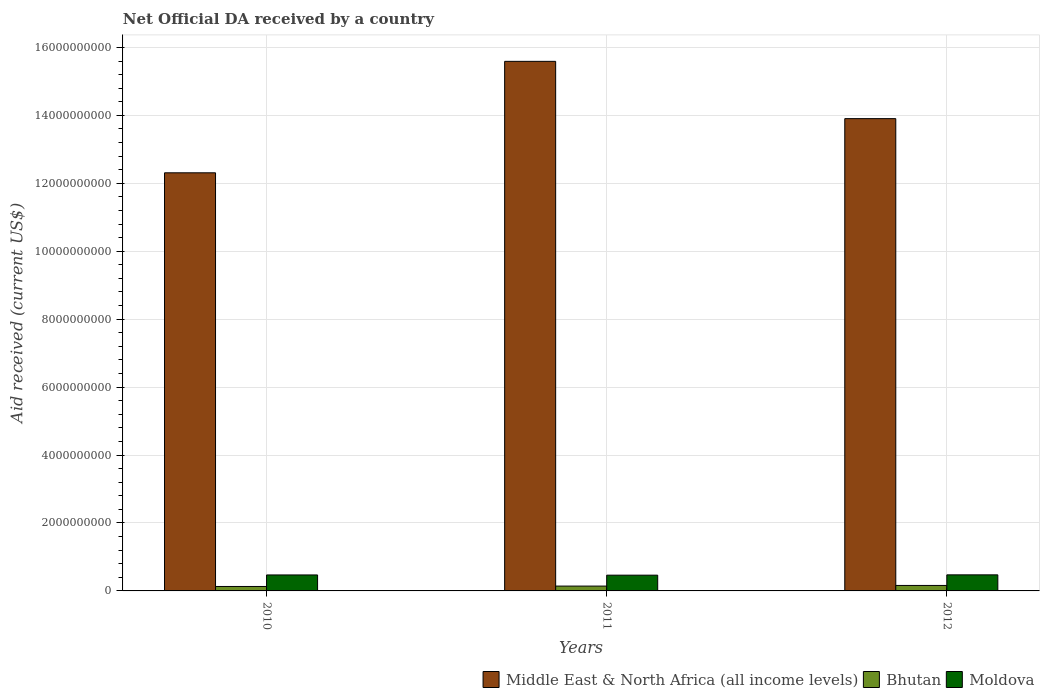How many groups of bars are there?
Offer a very short reply. 3. How many bars are there on the 3rd tick from the left?
Provide a succinct answer. 3. What is the label of the 2nd group of bars from the left?
Ensure brevity in your answer.  2011. In how many cases, is the number of bars for a given year not equal to the number of legend labels?
Offer a very short reply. 0. What is the net official development assistance aid received in Middle East & North Africa (all income levels) in 2010?
Your answer should be compact. 1.23e+1. Across all years, what is the maximum net official development assistance aid received in Bhutan?
Provide a succinct answer. 1.61e+08. Across all years, what is the minimum net official development assistance aid received in Middle East & North Africa (all income levels)?
Provide a short and direct response. 1.23e+1. In which year was the net official development assistance aid received in Middle East & North Africa (all income levels) maximum?
Your answer should be very brief. 2011. What is the total net official development assistance aid received in Bhutan in the graph?
Provide a succinct answer. 4.35e+08. What is the difference between the net official development assistance aid received in Moldova in 2011 and that in 2012?
Make the answer very short. -8.99e+06. What is the difference between the net official development assistance aid received in Moldova in 2010 and the net official development assistance aid received in Middle East & North Africa (all income levels) in 2012?
Your answer should be compact. -1.34e+1. What is the average net official development assistance aid received in Moldova per year?
Ensure brevity in your answer.  4.69e+08. In the year 2012, what is the difference between the net official development assistance aid received in Moldova and net official development assistance aid received in Bhutan?
Your answer should be compact. 3.12e+08. In how many years, is the net official development assistance aid received in Bhutan greater than 4400000000 US$?
Your answer should be compact. 0. What is the ratio of the net official development assistance aid received in Bhutan in 2010 to that in 2012?
Provide a short and direct response. 0.81. Is the difference between the net official development assistance aid received in Moldova in 2011 and 2012 greater than the difference between the net official development assistance aid received in Bhutan in 2011 and 2012?
Offer a very short reply. Yes. What is the difference between the highest and the second highest net official development assistance aid received in Middle East & North Africa (all income levels)?
Keep it short and to the point. 1.69e+09. What is the difference between the highest and the lowest net official development assistance aid received in Moldova?
Your answer should be very brief. 8.99e+06. In how many years, is the net official development assistance aid received in Middle East & North Africa (all income levels) greater than the average net official development assistance aid received in Middle East & North Africa (all income levels) taken over all years?
Offer a very short reply. 1. Is the sum of the net official development assistance aid received in Bhutan in 2011 and 2012 greater than the maximum net official development assistance aid received in Middle East & North Africa (all income levels) across all years?
Your answer should be very brief. No. What does the 3rd bar from the left in 2011 represents?
Give a very brief answer. Moldova. What does the 3rd bar from the right in 2010 represents?
Make the answer very short. Middle East & North Africa (all income levels). How many bars are there?
Offer a terse response. 9. How many years are there in the graph?
Your answer should be compact. 3. What is the difference between two consecutive major ticks on the Y-axis?
Ensure brevity in your answer.  2.00e+09. Does the graph contain any zero values?
Keep it short and to the point. No. Does the graph contain grids?
Your answer should be compact. Yes. How many legend labels are there?
Offer a terse response. 3. How are the legend labels stacked?
Your answer should be compact. Horizontal. What is the title of the graph?
Give a very brief answer. Net Official DA received by a country. What is the label or title of the X-axis?
Your answer should be very brief. Years. What is the label or title of the Y-axis?
Your response must be concise. Aid received (current US$). What is the Aid received (current US$) of Middle East & North Africa (all income levels) in 2010?
Your answer should be compact. 1.23e+1. What is the Aid received (current US$) of Bhutan in 2010?
Make the answer very short. 1.31e+08. What is the Aid received (current US$) in Moldova in 2010?
Make the answer very short. 4.70e+08. What is the Aid received (current US$) in Middle East & North Africa (all income levels) in 2011?
Your response must be concise. 1.56e+1. What is the Aid received (current US$) of Bhutan in 2011?
Keep it short and to the point. 1.42e+08. What is the Aid received (current US$) in Moldova in 2011?
Offer a terse response. 4.64e+08. What is the Aid received (current US$) of Middle East & North Africa (all income levels) in 2012?
Your answer should be compact. 1.39e+1. What is the Aid received (current US$) in Bhutan in 2012?
Your response must be concise. 1.61e+08. What is the Aid received (current US$) in Moldova in 2012?
Your answer should be very brief. 4.73e+08. Across all years, what is the maximum Aid received (current US$) of Middle East & North Africa (all income levels)?
Your answer should be very brief. 1.56e+1. Across all years, what is the maximum Aid received (current US$) of Bhutan?
Your answer should be compact. 1.61e+08. Across all years, what is the maximum Aid received (current US$) of Moldova?
Make the answer very short. 4.73e+08. Across all years, what is the minimum Aid received (current US$) in Middle East & North Africa (all income levels)?
Offer a very short reply. 1.23e+1. Across all years, what is the minimum Aid received (current US$) in Bhutan?
Your answer should be compact. 1.31e+08. Across all years, what is the minimum Aid received (current US$) in Moldova?
Keep it short and to the point. 4.64e+08. What is the total Aid received (current US$) in Middle East & North Africa (all income levels) in the graph?
Give a very brief answer. 4.18e+1. What is the total Aid received (current US$) of Bhutan in the graph?
Your answer should be very brief. 4.35e+08. What is the total Aid received (current US$) in Moldova in the graph?
Give a very brief answer. 1.41e+09. What is the difference between the Aid received (current US$) of Middle East & North Africa (all income levels) in 2010 and that in 2011?
Keep it short and to the point. -3.28e+09. What is the difference between the Aid received (current US$) of Bhutan in 2010 and that in 2011?
Offer a terse response. -1.14e+07. What is the difference between the Aid received (current US$) in Moldova in 2010 and that in 2011?
Keep it short and to the point. 6.31e+06. What is the difference between the Aid received (current US$) in Middle East & North Africa (all income levels) in 2010 and that in 2012?
Your answer should be very brief. -1.59e+09. What is the difference between the Aid received (current US$) in Bhutan in 2010 and that in 2012?
Your answer should be compact. -3.03e+07. What is the difference between the Aid received (current US$) in Moldova in 2010 and that in 2012?
Provide a short and direct response. -2.68e+06. What is the difference between the Aid received (current US$) of Middle East & North Africa (all income levels) in 2011 and that in 2012?
Offer a very short reply. 1.69e+09. What is the difference between the Aid received (current US$) in Bhutan in 2011 and that in 2012?
Provide a short and direct response. -1.88e+07. What is the difference between the Aid received (current US$) in Moldova in 2011 and that in 2012?
Offer a terse response. -8.99e+06. What is the difference between the Aid received (current US$) in Middle East & North Africa (all income levels) in 2010 and the Aid received (current US$) in Bhutan in 2011?
Your response must be concise. 1.22e+1. What is the difference between the Aid received (current US$) of Middle East & North Africa (all income levels) in 2010 and the Aid received (current US$) of Moldova in 2011?
Keep it short and to the point. 1.18e+1. What is the difference between the Aid received (current US$) of Bhutan in 2010 and the Aid received (current US$) of Moldova in 2011?
Your answer should be compact. -3.33e+08. What is the difference between the Aid received (current US$) in Middle East & North Africa (all income levels) in 2010 and the Aid received (current US$) in Bhutan in 2012?
Give a very brief answer. 1.21e+1. What is the difference between the Aid received (current US$) of Middle East & North Africa (all income levels) in 2010 and the Aid received (current US$) of Moldova in 2012?
Make the answer very short. 1.18e+1. What is the difference between the Aid received (current US$) of Bhutan in 2010 and the Aid received (current US$) of Moldova in 2012?
Ensure brevity in your answer.  -3.42e+08. What is the difference between the Aid received (current US$) of Middle East & North Africa (all income levels) in 2011 and the Aid received (current US$) of Bhutan in 2012?
Make the answer very short. 1.54e+1. What is the difference between the Aid received (current US$) in Middle East & North Africa (all income levels) in 2011 and the Aid received (current US$) in Moldova in 2012?
Keep it short and to the point. 1.51e+1. What is the difference between the Aid received (current US$) of Bhutan in 2011 and the Aid received (current US$) of Moldova in 2012?
Provide a succinct answer. -3.31e+08. What is the average Aid received (current US$) of Middle East & North Africa (all income levels) per year?
Offer a terse response. 1.39e+1. What is the average Aid received (current US$) in Bhutan per year?
Provide a succinct answer. 1.45e+08. What is the average Aid received (current US$) in Moldova per year?
Ensure brevity in your answer.  4.69e+08. In the year 2010, what is the difference between the Aid received (current US$) of Middle East & North Africa (all income levels) and Aid received (current US$) of Bhutan?
Make the answer very short. 1.22e+1. In the year 2010, what is the difference between the Aid received (current US$) in Middle East & North Africa (all income levels) and Aid received (current US$) in Moldova?
Ensure brevity in your answer.  1.18e+1. In the year 2010, what is the difference between the Aid received (current US$) of Bhutan and Aid received (current US$) of Moldova?
Offer a terse response. -3.39e+08. In the year 2011, what is the difference between the Aid received (current US$) of Middle East & North Africa (all income levels) and Aid received (current US$) of Bhutan?
Your response must be concise. 1.54e+1. In the year 2011, what is the difference between the Aid received (current US$) of Middle East & North Africa (all income levels) and Aid received (current US$) of Moldova?
Keep it short and to the point. 1.51e+1. In the year 2011, what is the difference between the Aid received (current US$) in Bhutan and Aid received (current US$) in Moldova?
Provide a succinct answer. -3.22e+08. In the year 2012, what is the difference between the Aid received (current US$) in Middle East & North Africa (all income levels) and Aid received (current US$) in Bhutan?
Your answer should be compact. 1.37e+1. In the year 2012, what is the difference between the Aid received (current US$) of Middle East & North Africa (all income levels) and Aid received (current US$) of Moldova?
Your answer should be very brief. 1.34e+1. In the year 2012, what is the difference between the Aid received (current US$) of Bhutan and Aid received (current US$) of Moldova?
Your answer should be very brief. -3.12e+08. What is the ratio of the Aid received (current US$) of Middle East & North Africa (all income levels) in 2010 to that in 2011?
Offer a very short reply. 0.79. What is the ratio of the Aid received (current US$) in Bhutan in 2010 to that in 2011?
Provide a short and direct response. 0.92. What is the ratio of the Aid received (current US$) of Moldova in 2010 to that in 2011?
Your answer should be compact. 1.01. What is the ratio of the Aid received (current US$) in Middle East & North Africa (all income levels) in 2010 to that in 2012?
Your answer should be very brief. 0.89. What is the ratio of the Aid received (current US$) in Bhutan in 2010 to that in 2012?
Offer a very short reply. 0.81. What is the ratio of the Aid received (current US$) of Middle East & North Africa (all income levels) in 2011 to that in 2012?
Your response must be concise. 1.12. What is the ratio of the Aid received (current US$) in Bhutan in 2011 to that in 2012?
Give a very brief answer. 0.88. What is the ratio of the Aid received (current US$) in Moldova in 2011 to that in 2012?
Make the answer very short. 0.98. What is the difference between the highest and the second highest Aid received (current US$) in Middle East & North Africa (all income levels)?
Provide a succinct answer. 1.69e+09. What is the difference between the highest and the second highest Aid received (current US$) of Bhutan?
Your response must be concise. 1.88e+07. What is the difference between the highest and the second highest Aid received (current US$) in Moldova?
Provide a succinct answer. 2.68e+06. What is the difference between the highest and the lowest Aid received (current US$) of Middle East & North Africa (all income levels)?
Provide a succinct answer. 3.28e+09. What is the difference between the highest and the lowest Aid received (current US$) in Bhutan?
Make the answer very short. 3.03e+07. What is the difference between the highest and the lowest Aid received (current US$) in Moldova?
Offer a terse response. 8.99e+06. 